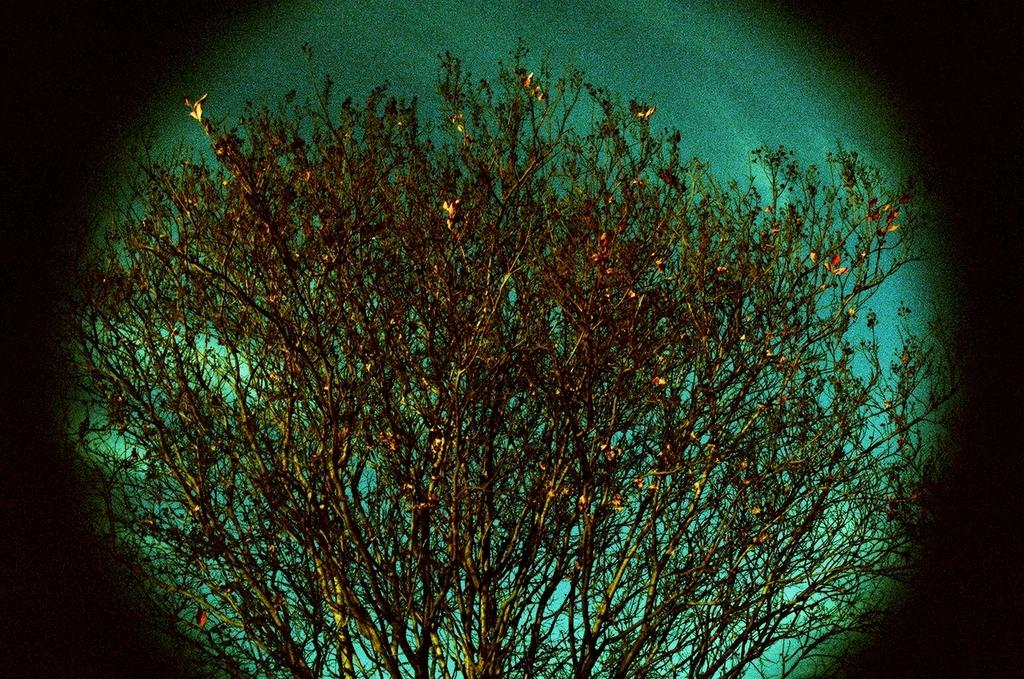What type of vegetation can be seen in the image? There are trees in the image. What part of the natural environment is visible in the image? The sky is visible in the background of the image. How would you describe the lighting in the image? The image appears to be a bit dark. Who is the owner of the insurance market in the image? There is no insurance market or owner present in the image; it features trees and a sky background. 